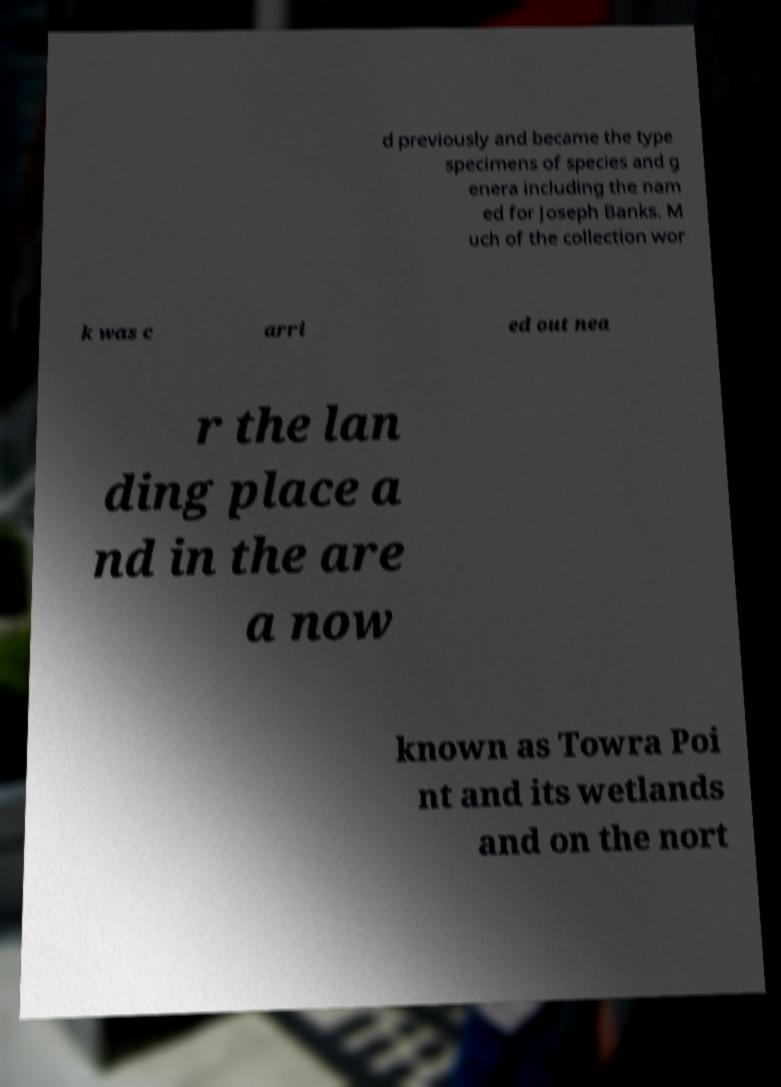Please identify and transcribe the text found in this image. d previously and became the type specimens of species and g enera including the nam ed for Joseph Banks. M uch of the collection wor k was c arri ed out nea r the lan ding place a nd in the are a now known as Towra Poi nt and its wetlands and on the nort 